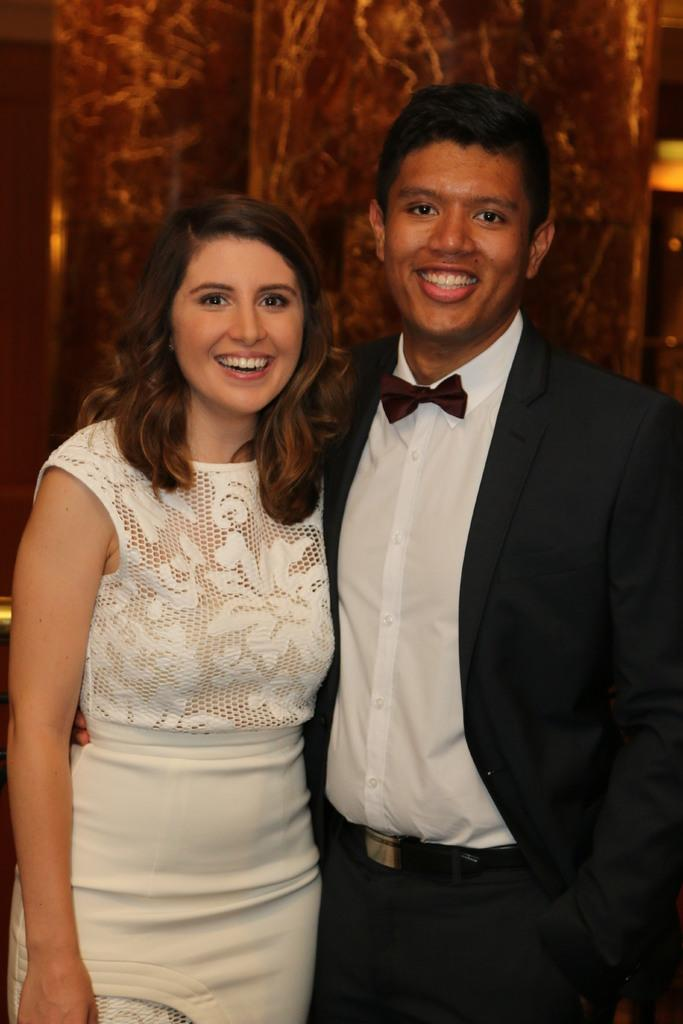How many people are in the image? There are two people in the image. What are the people doing in the image? The people are standing on a path and smiling. What can be seen behind the people? There appears to be a pillar behind the people. What type of building is visible in the image? There is no building visible in the image; only a path and a pillar are present. How does the ray of light affect the people in the image? There is no ray of light present in the image, so its effect on the people cannot be determined. 